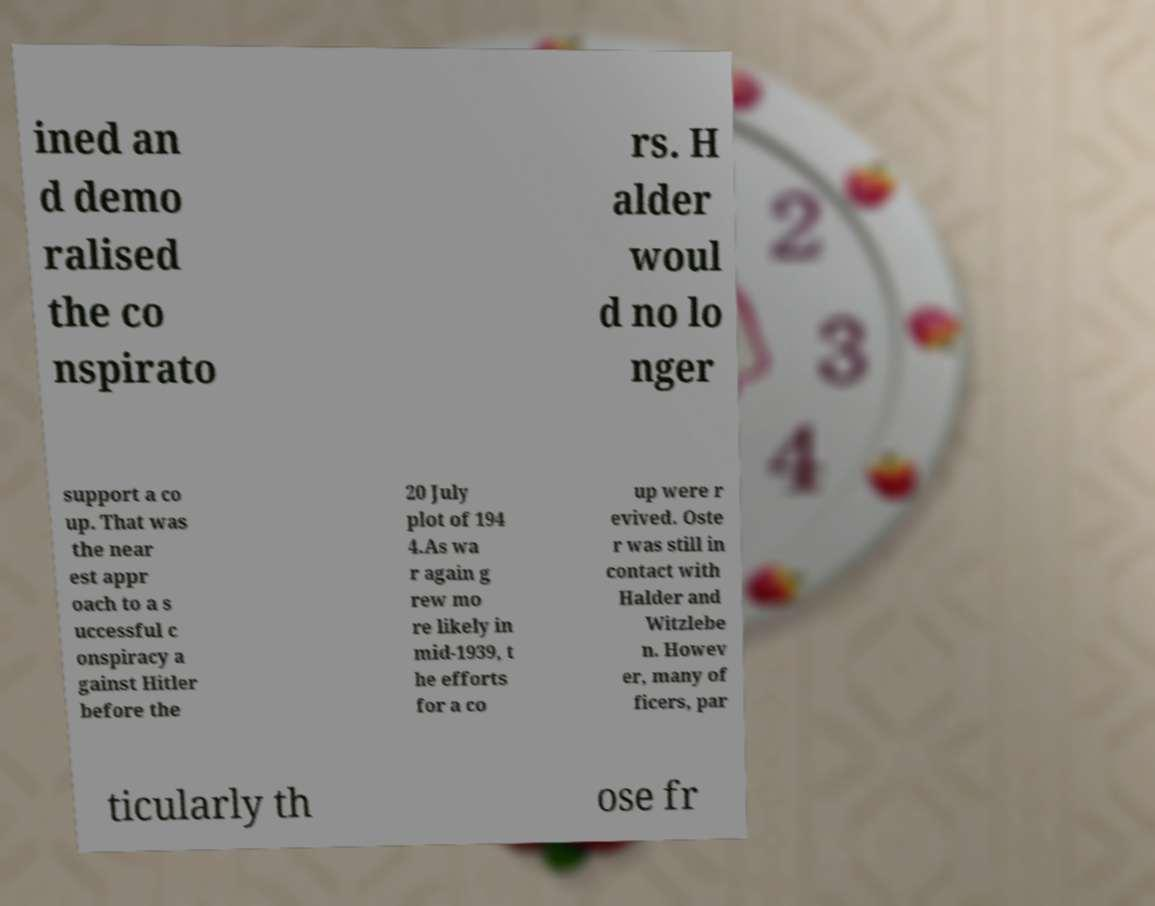Can you read and provide the text displayed in the image?This photo seems to have some interesting text. Can you extract and type it out for me? ined an d demo ralised the co nspirato rs. H alder woul d no lo nger support a co up. That was the near est appr oach to a s uccessful c onspiracy a gainst Hitler before the 20 July plot of 194 4.As wa r again g rew mo re likely in mid-1939, t he efforts for a co up were r evived. Oste r was still in contact with Halder and Witzlebe n. Howev er, many of ficers, par ticularly th ose fr 